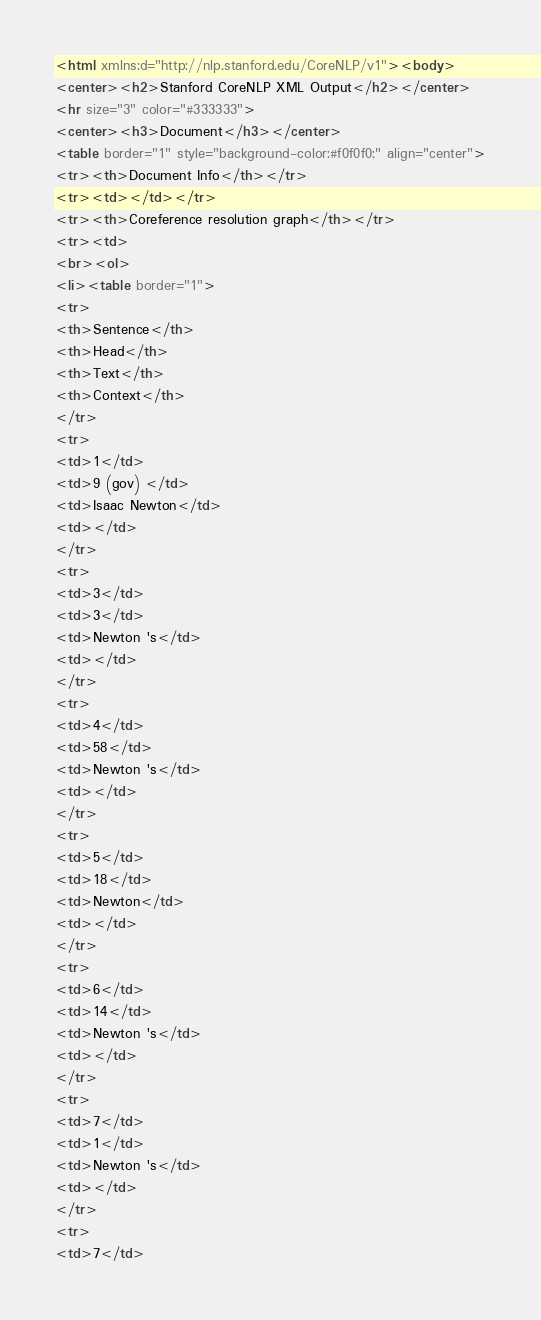<code> <loc_0><loc_0><loc_500><loc_500><_HTML_><html xmlns:d="http://nlp.stanford.edu/CoreNLP/v1"><body>
<center><h2>Stanford CoreNLP XML Output</h2></center>
<hr size="3" color="#333333">
<center><h3>Document</h3></center>
<table border="1" style="background-color:#f0f0f0;" align="center">
<tr><th>Document Info</th></tr>
<tr><td></td></tr>
<tr><th>Coreference resolution graph</th></tr>
<tr><td>
<br><ol>
<li><table border="1">
<tr>
<th>Sentence</th>
<th>Head</th>
<th>Text</th>
<th>Context</th>
</tr>
<tr>
<td>1</td>
<td>9 (gov) </td>
<td>Isaac Newton</td>
<td></td>
</tr>
<tr>
<td>3</td>
<td>3</td>
<td>Newton 's</td>
<td></td>
</tr>
<tr>
<td>4</td>
<td>58</td>
<td>Newton 's</td>
<td></td>
</tr>
<tr>
<td>5</td>
<td>18</td>
<td>Newton</td>
<td></td>
</tr>
<tr>
<td>6</td>
<td>14</td>
<td>Newton 's</td>
<td></td>
</tr>
<tr>
<td>7</td>
<td>1</td>
<td>Newton 's</td>
<td></td>
</tr>
<tr>
<td>7</td></code> 